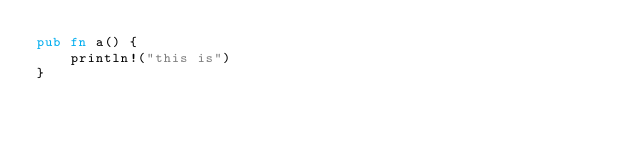<code> <loc_0><loc_0><loc_500><loc_500><_Rust_>pub fn a() {
    println!("this is")
}
</code> 